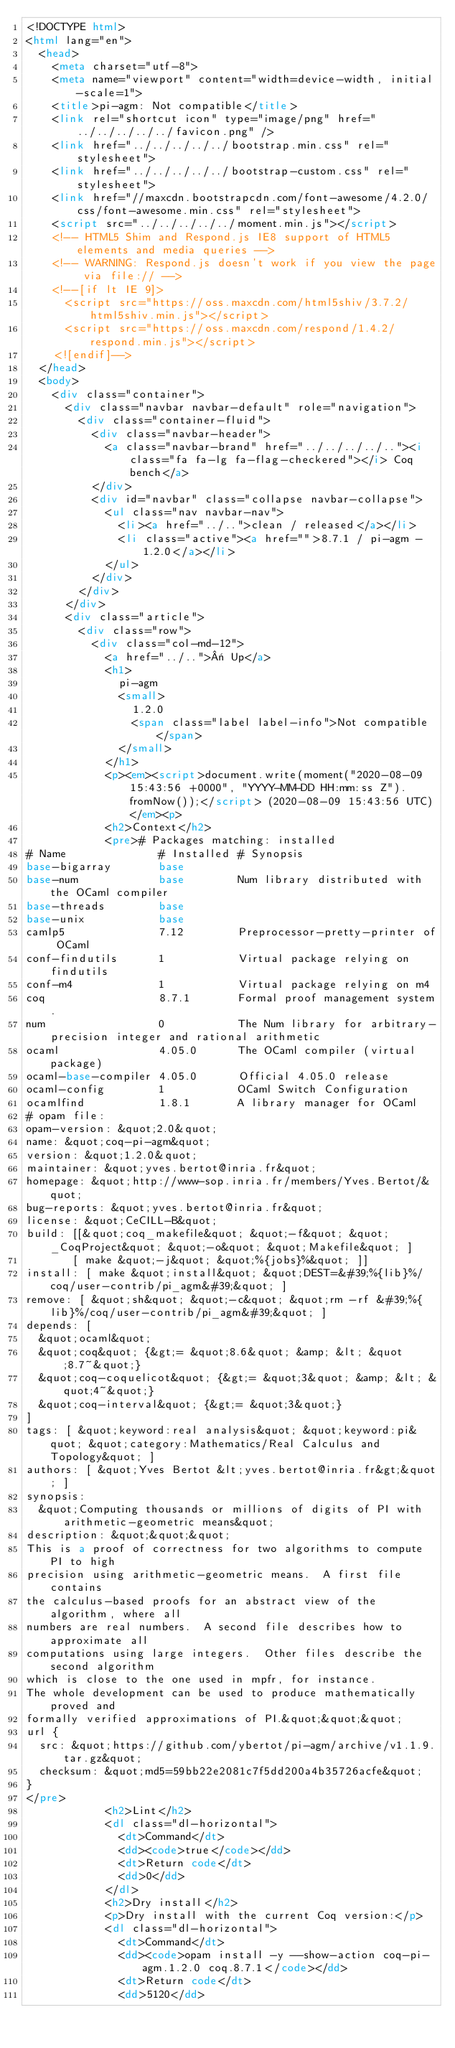Convert code to text. <code><loc_0><loc_0><loc_500><loc_500><_HTML_><!DOCTYPE html>
<html lang="en">
  <head>
    <meta charset="utf-8">
    <meta name="viewport" content="width=device-width, initial-scale=1">
    <title>pi-agm: Not compatible</title>
    <link rel="shortcut icon" type="image/png" href="../../../../../favicon.png" />
    <link href="../../../../../bootstrap.min.css" rel="stylesheet">
    <link href="../../../../../bootstrap-custom.css" rel="stylesheet">
    <link href="//maxcdn.bootstrapcdn.com/font-awesome/4.2.0/css/font-awesome.min.css" rel="stylesheet">
    <script src="../../../../../moment.min.js"></script>
    <!-- HTML5 Shim and Respond.js IE8 support of HTML5 elements and media queries -->
    <!-- WARNING: Respond.js doesn't work if you view the page via file:// -->
    <!--[if lt IE 9]>
      <script src="https://oss.maxcdn.com/html5shiv/3.7.2/html5shiv.min.js"></script>
      <script src="https://oss.maxcdn.com/respond/1.4.2/respond.min.js"></script>
    <![endif]-->
  </head>
  <body>
    <div class="container">
      <div class="navbar navbar-default" role="navigation">
        <div class="container-fluid">
          <div class="navbar-header">
            <a class="navbar-brand" href="../../../../.."><i class="fa fa-lg fa-flag-checkered"></i> Coq bench</a>
          </div>
          <div id="navbar" class="collapse navbar-collapse">
            <ul class="nav navbar-nav">
              <li><a href="../..">clean / released</a></li>
              <li class="active"><a href="">8.7.1 / pi-agm - 1.2.0</a></li>
            </ul>
          </div>
        </div>
      </div>
      <div class="article">
        <div class="row">
          <div class="col-md-12">
            <a href="../..">« Up</a>
            <h1>
              pi-agm
              <small>
                1.2.0
                <span class="label label-info">Not compatible</span>
              </small>
            </h1>
            <p><em><script>document.write(moment("2020-08-09 15:43:56 +0000", "YYYY-MM-DD HH:mm:ss Z").fromNow());</script> (2020-08-09 15:43:56 UTC)</em><p>
            <h2>Context</h2>
            <pre># Packages matching: installed
# Name              # Installed # Synopsis
base-bigarray       base
base-num            base        Num library distributed with the OCaml compiler
base-threads        base
base-unix           base
camlp5              7.12        Preprocessor-pretty-printer of OCaml
conf-findutils      1           Virtual package relying on findutils
conf-m4             1           Virtual package relying on m4
coq                 8.7.1       Formal proof management system.
num                 0           The Num library for arbitrary-precision integer and rational arithmetic
ocaml               4.05.0      The OCaml compiler (virtual package)
ocaml-base-compiler 4.05.0      Official 4.05.0 release
ocaml-config        1           OCaml Switch Configuration
ocamlfind           1.8.1       A library manager for OCaml
# opam file:
opam-version: &quot;2.0&quot;
name: &quot;coq-pi-agm&quot;
version: &quot;1.2.0&quot;
maintainer: &quot;yves.bertot@inria.fr&quot;
homepage: &quot;http://www-sop.inria.fr/members/Yves.Bertot/&quot;
bug-reports: &quot;yves.bertot@inria.fr&quot;
license: &quot;CeCILL-B&quot;
build: [[&quot;coq_makefile&quot; &quot;-f&quot; &quot;_CoqProject&quot; &quot;-o&quot; &quot;Makefile&quot; ]
       [ make &quot;-j&quot; &quot;%{jobs}%&quot; ]]
install: [ make &quot;install&quot; &quot;DEST=&#39;%{lib}%/coq/user-contrib/pi_agm&#39;&quot; ]
remove: [ &quot;sh&quot; &quot;-c&quot; &quot;rm -rf &#39;%{lib}%/coq/user-contrib/pi_agm&#39;&quot; ]
depends: [
  &quot;ocaml&quot;
  &quot;coq&quot; {&gt;= &quot;8.6&quot; &amp; &lt; &quot;8.7~&quot;}
  &quot;coq-coquelicot&quot; {&gt;= &quot;3&quot; &amp; &lt; &quot;4~&quot;}
  &quot;coq-interval&quot; {&gt;= &quot;3&quot;}
]
tags: [ &quot;keyword:real analysis&quot; &quot;keyword:pi&quot; &quot;category:Mathematics/Real Calculus and Topology&quot; ]
authors: [ &quot;Yves Bertot &lt;yves.bertot@inria.fr&gt;&quot; ]
synopsis:
  &quot;Computing thousands or millions of digits of PI with arithmetic-geometric means&quot;
description: &quot;&quot;&quot;
This is a proof of correctness for two algorithms to compute PI to high
precision using arithmetic-geometric means.  A first file contains
the calculus-based proofs for an abstract view of the algorithm, where all
numbers are real numbers.  A second file describes how to approximate all
computations using large integers.  Other files describe the second algorithm
which is close to the one used in mpfr, for instance. 
The whole development can be used to produce mathematically proved and
formally verified approximations of PI.&quot;&quot;&quot;
url {
  src: &quot;https://github.com/ybertot/pi-agm/archive/v1.1.9.tar.gz&quot;
  checksum: &quot;md5=59bb22e2081c7f5dd200a4b35726acfe&quot;
}
</pre>
            <h2>Lint</h2>
            <dl class="dl-horizontal">
              <dt>Command</dt>
              <dd><code>true</code></dd>
              <dt>Return code</dt>
              <dd>0</dd>
            </dl>
            <h2>Dry install</h2>
            <p>Dry install with the current Coq version:</p>
            <dl class="dl-horizontal">
              <dt>Command</dt>
              <dd><code>opam install -y --show-action coq-pi-agm.1.2.0 coq.8.7.1</code></dd>
              <dt>Return code</dt>
              <dd>5120</dd></code> 